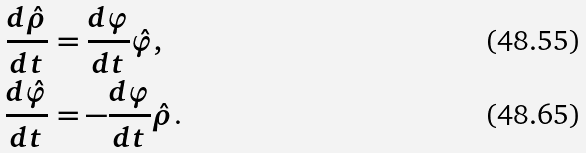<formula> <loc_0><loc_0><loc_500><loc_500>\frac { d \hat { \rho } } { d t } & = \frac { d \varphi } { d t } \hat { \varphi } , \\ \frac { d \hat { \varphi } } { d t } & = - \frac { d \varphi } { d t } \hat { \rho } \text {.}</formula> 